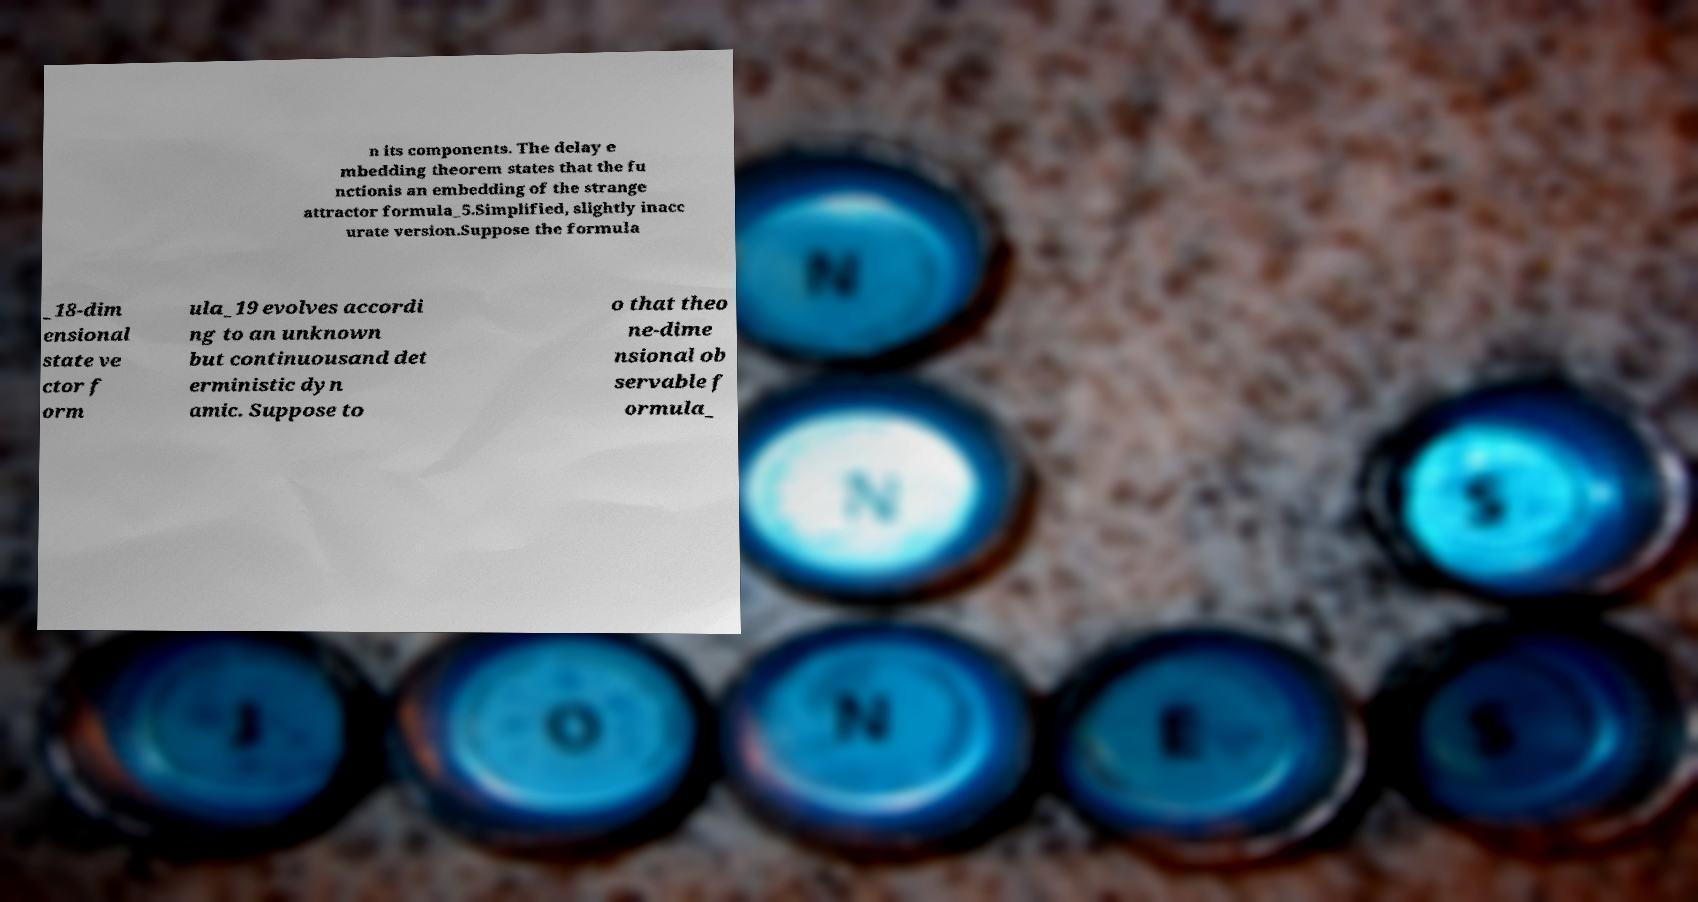For documentation purposes, I need the text within this image transcribed. Could you provide that? n its components. The delay e mbedding theorem states that the fu nctionis an embedding of the strange attractor formula_5.Simplified, slightly inacc urate version.Suppose the formula _18-dim ensional state ve ctor f orm ula_19 evolves accordi ng to an unknown but continuousand det erministic dyn amic. Suppose to o that theo ne-dime nsional ob servable f ormula_ 